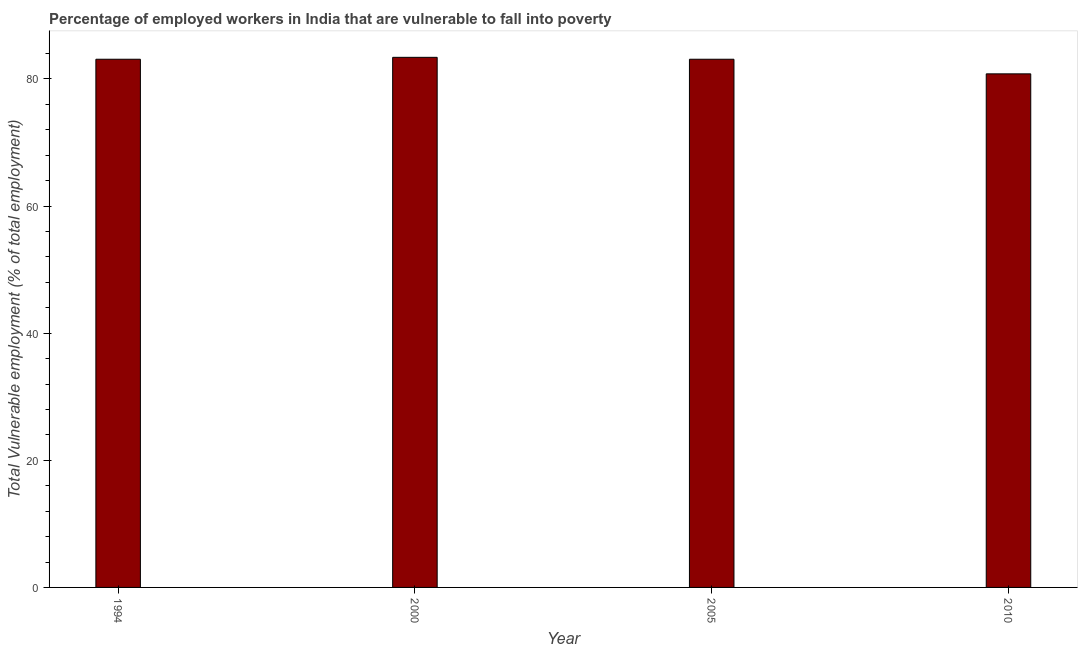Does the graph contain grids?
Your answer should be compact. No. What is the title of the graph?
Your answer should be compact. Percentage of employed workers in India that are vulnerable to fall into poverty. What is the label or title of the X-axis?
Give a very brief answer. Year. What is the label or title of the Y-axis?
Make the answer very short. Total Vulnerable employment (% of total employment). What is the total vulnerable employment in 2005?
Your response must be concise. 83.1. Across all years, what is the maximum total vulnerable employment?
Ensure brevity in your answer.  83.4. Across all years, what is the minimum total vulnerable employment?
Your response must be concise. 80.8. In which year was the total vulnerable employment maximum?
Your answer should be compact. 2000. In which year was the total vulnerable employment minimum?
Keep it short and to the point. 2010. What is the sum of the total vulnerable employment?
Your answer should be compact. 330.4. What is the difference between the total vulnerable employment in 1994 and 2000?
Your response must be concise. -0.3. What is the average total vulnerable employment per year?
Provide a short and direct response. 82.6. What is the median total vulnerable employment?
Offer a terse response. 83.1. Do a majority of the years between 2000 and 2010 (inclusive) have total vulnerable employment greater than 48 %?
Provide a short and direct response. Yes. What is the ratio of the total vulnerable employment in 2000 to that in 2010?
Give a very brief answer. 1.03. What is the difference between the highest and the lowest total vulnerable employment?
Your answer should be very brief. 2.6. Are all the bars in the graph horizontal?
Keep it short and to the point. No. What is the difference between two consecutive major ticks on the Y-axis?
Offer a very short reply. 20. Are the values on the major ticks of Y-axis written in scientific E-notation?
Ensure brevity in your answer.  No. What is the Total Vulnerable employment (% of total employment) in 1994?
Provide a succinct answer. 83.1. What is the Total Vulnerable employment (% of total employment) of 2000?
Your answer should be compact. 83.4. What is the Total Vulnerable employment (% of total employment) in 2005?
Keep it short and to the point. 83.1. What is the Total Vulnerable employment (% of total employment) of 2010?
Provide a short and direct response. 80.8. What is the difference between the Total Vulnerable employment (% of total employment) in 2005 and 2010?
Ensure brevity in your answer.  2.3. What is the ratio of the Total Vulnerable employment (% of total employment) in 1994 to that in 2000?
Offer a terse response. 1. What is the ratio of the Total Vulnerable employment (% of total employment) in 1994 to that in 2010?
Make the answer very short. 1.03. What is the ratio of the Total Vulnerable employment (% of total employment) in 2000 to that in 2010?
Provide a short and direct response. 1.03. What is the ratio of the Total Vulnerable employment (% of total employment) in 2005 to that in 2010?
Ensure brevity in your answer.  1.03. 